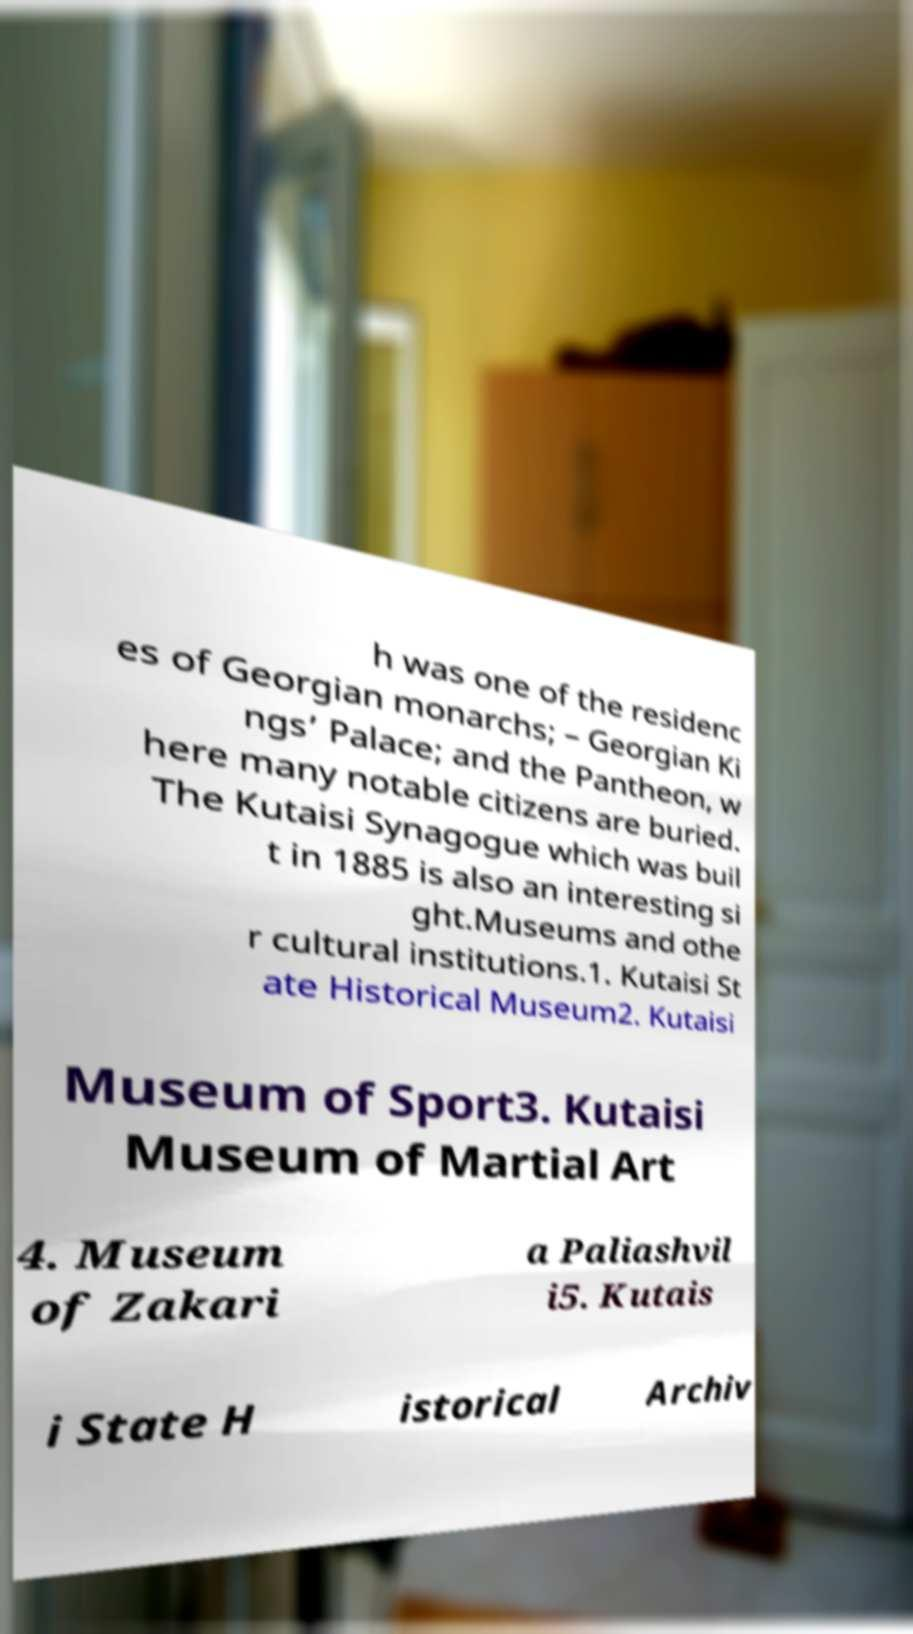Could you extract and type out the text from this image? h was one of the residenc es of Georgian monarchs; – Georgian Ki ngs’ Palace; and the Pantheon, w here many notable citizens are buried. The Kutaisi Synagogue which was buil t in 1885 is also an interesting si ght.Museums and othe r cultural institutions.1. Kutaisi St ate Historical Museum2. Kutaisi Museum of Sport3. Kutaisi Museum of Martial Art 4. Museum of Zakari a Paliashvil i5. Kutais i State H istorical Archiv 